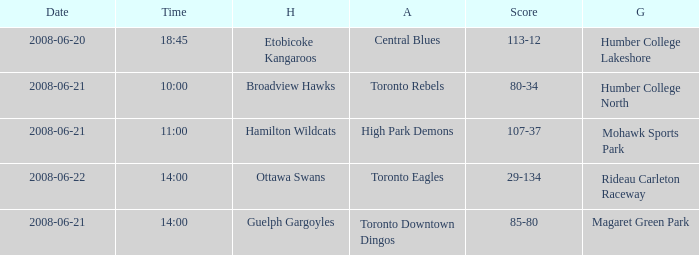What is the Ground with a Date that is 2008-06-20? Humber College Lakeshore. 